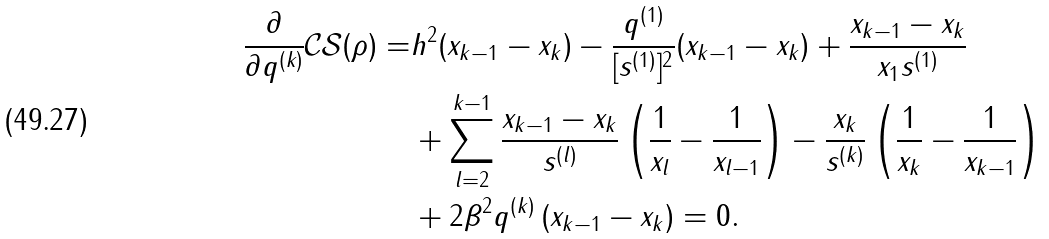Convert formula to latex. <formula><loc_0><loc_0><loc_500><loc_500>\frac { \partial } { \partial q ^ { ( k ) } } \mathcal { C S } ( \rho ) = & h ^ { 2 } ( x _ { k - 1 } - x _ { k } ) - \frac { q ^ { ( 1 ) } } { [ s ^ { ( 1 ) } ] ^ { 2 } } ( x _ { k - 1 } - x _ { k } ) + \frac { x _ { k - 1 } - x _ { k } } { x _ { 1 } s ^ { ( 1 ) } } \\ & + \sum _ { l = 2 } ^ { k - 1 } \frac { x _ { k - 1 } - x _ { k } } { s ^ { ( l ) } } \left ( \frac { 1 } { x _ { l } } - \frac { 1 } { x _ { l - 1 } } \right ) - \frac { x _ { k } } { s ^ { ( k ) } } \left ( \frac { 1 } { x _ { k } } - \frac { 1 } { x _ { k - 1 } } \right ) \\ & + 2 \beta ^ { 2 } q ^ { ( k ) } \left ( x _ { k - 1 } - x _ { k } \right ) = 0 .</formula> 